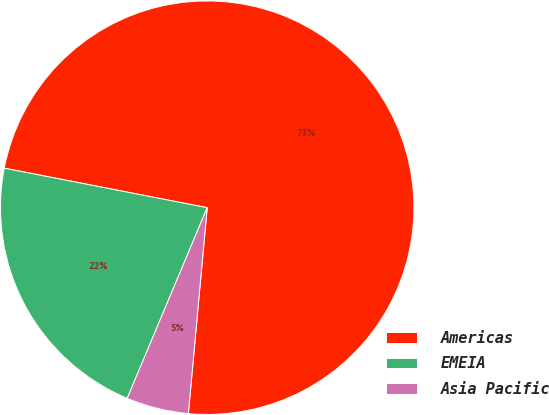<chart> <loc_0><loc_0><loc_500><loc_500><pie_chart><fcel>Americas<fcel>EMEIA<fcel>Asia Pacific<nl><fcel>73.4%<fcel>21.74%<fcel>4.87%<nl></chart> 